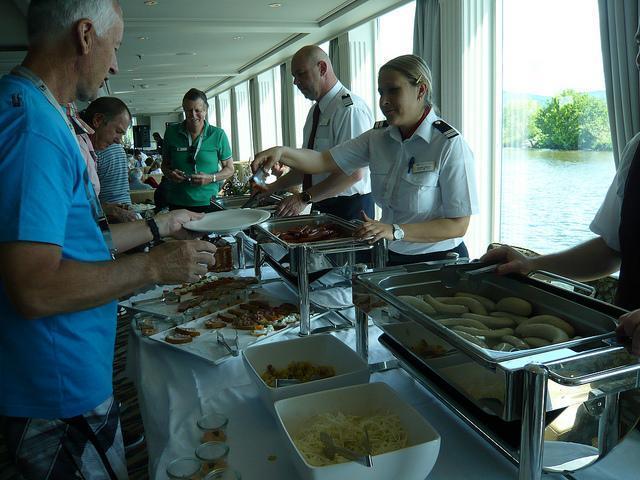How many people are in the picture?
Give a very brief answer. 6. How many bowls can you see?
Give a very brief answer. 2. 